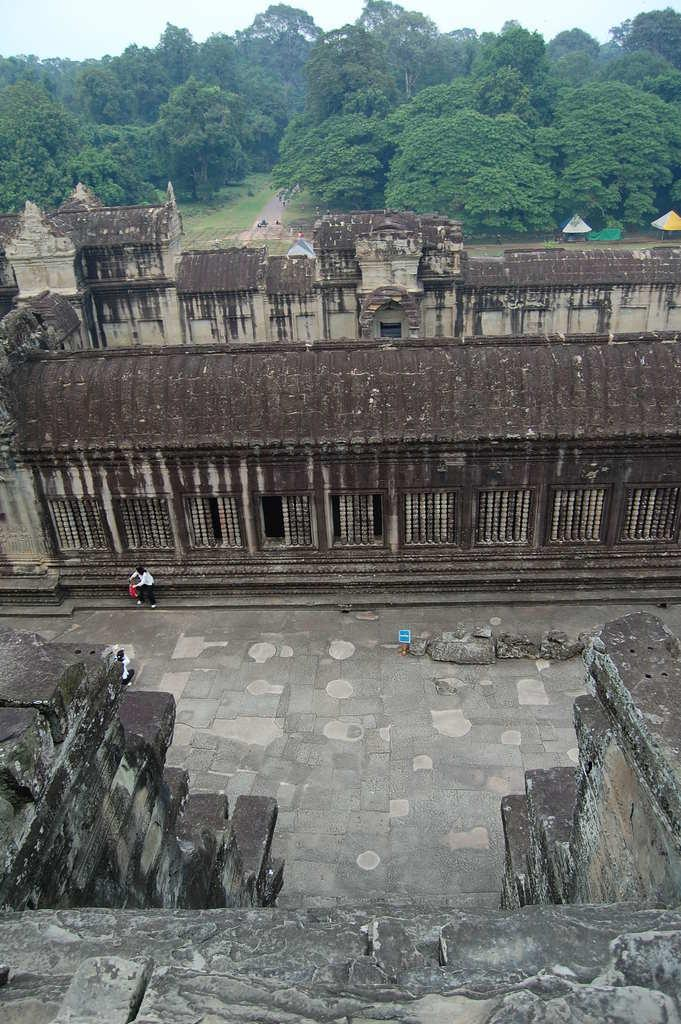Who or what can be seen in the image? There are people in the image. What type of structure is visible in the image? There is a fort in the image. What else can be seen in the image besides the fort? Rooftops are visible in the image. What is present in the background of the image? There are tents, trees, a road, and the sky visible in the background of the image. What type of account does the achiever have in the image? There is no mention of an achiever or an account in the image. The image features people, a fort, rooftops, tents, trees, a road, and the sky. 